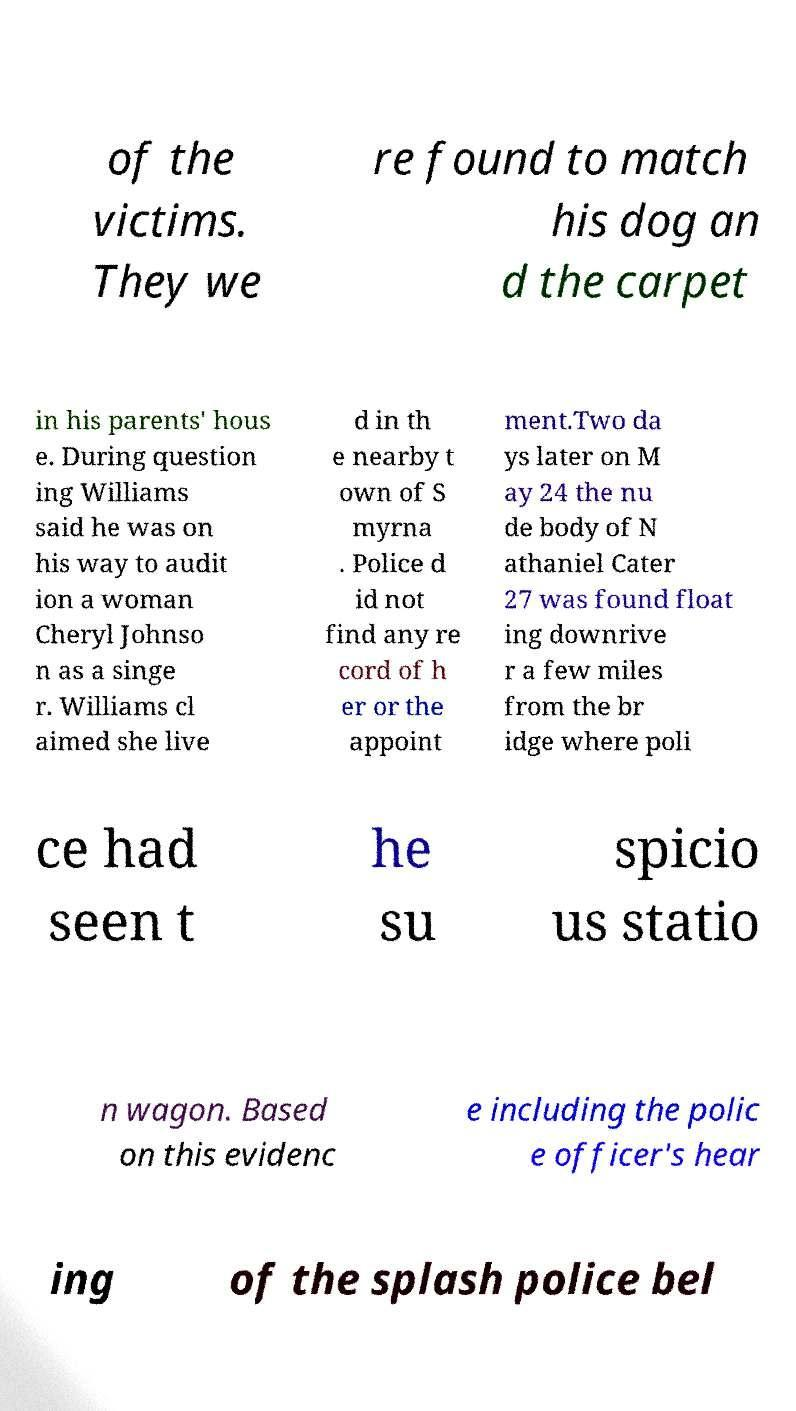Can you read and provide the text displayed in the image?This photo seems to have some interesting text. Can you extract and type it out for me? of the victims. They we re found to match his dog an d the carpet in his parents' hous e. During question ing Williams said he was on his way to audit ion a woman Cheryl Johnso n as a singe r. Williams cl aimed she live d in th e nearby t own of S myrna . Police d id not find any re cord of h er or the appoint ment.Two da ys later on M ay 24 the nu de body of N athaniel Cater 27 was found float ing downrive r a few miles from the br idge where poli ce had seen t he su spicio us statio n wagon. Based on this evidenc e including the polic e officer's hear ing of the splash police bel 